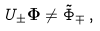Convert formula to latex. <formula><loc_0><loc_0><loc_500><loc_500>U _ { \pm } { \mathbf \Phi } \neq \tilde { \Phi } _ { \mp } \, ,</formula> 